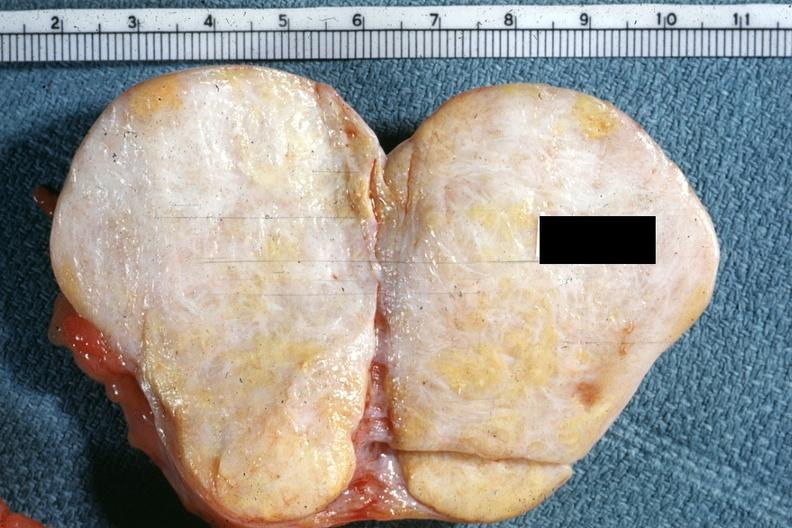s there no ovary present to indicate the location of the tumor mass?
Answer the question using a single word or phrase. Yes 